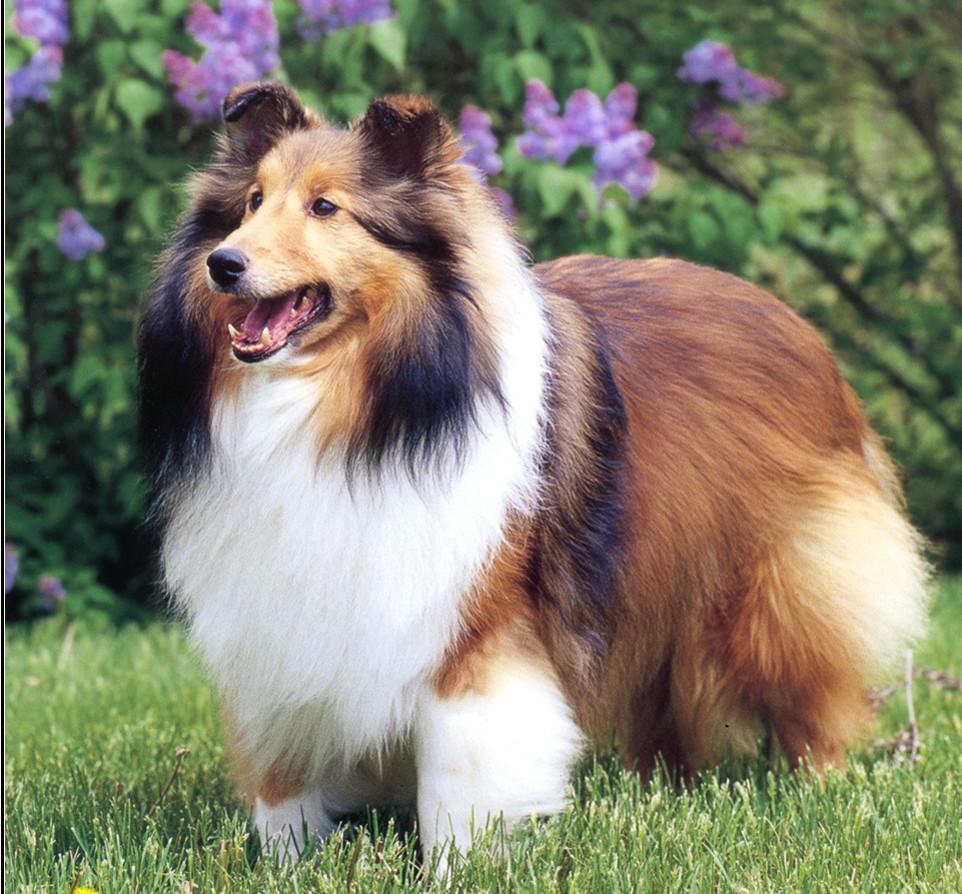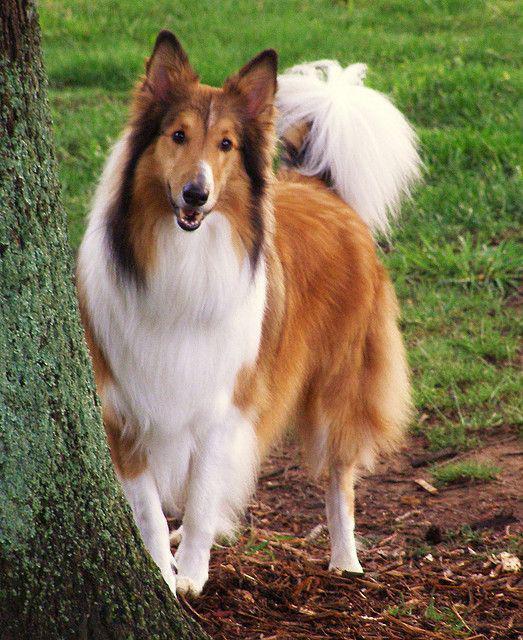The first image is the image on the left, the second image is the image on the right. Examine the images to the left and right. Is the description "The dog in the image on the right is not standing on grass." accurate? Answer yes or no. Yes. 